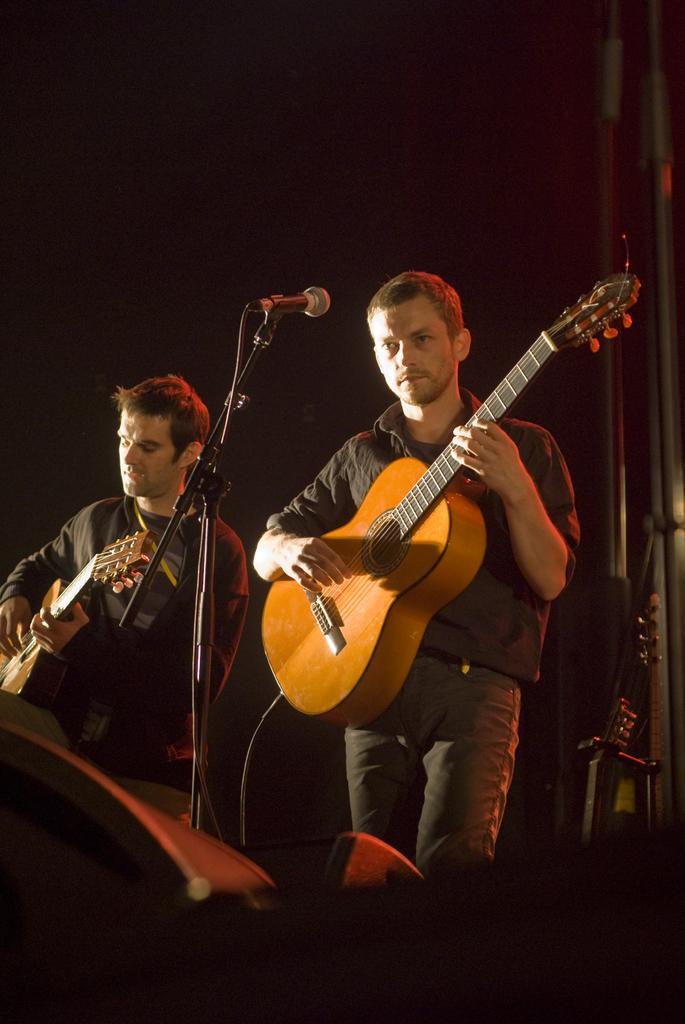Please provide a concise description of this image. In this image there are two persons standing and playing guitar. Before them there is a mike stand. 